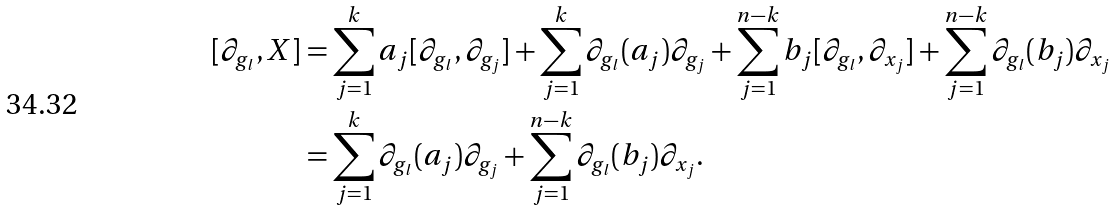Convert formula to latex. <formula><loc_0><loc_0><loc_500><loc_500>[ \partial _ { g _ { l } } , X ] & = \sum _ { j = 1 } ^ { k } a _ { j } [ \partial _ { g _ { l } } , \partial _ { g _ { j } } ] + \sum _ { j = 1 } ^ { k } \partial _ { g _ { l } } ( a _ { j } ) \partial _ { g _ { j } } + \sum _ { j = 1 } ^ { n - k } b _ { j } [ \partial _ { g _ { l } } , \partial _ { x _ { j } } ] + \sum _ { j = 1 } ^ { n - k } \partial _ { g _ { l } } ( b _ { j } ) \partial _ { x _ { j } } \\ & = \sum _ { j = 1 } ^ { k } \partial _ { g _ { l } } ( a _ { j } ) \partial _ { g _ { j } } + \sum _ { j = 1 } ^ { n - k } \partial _ { g _ { l } } ( b _ { j } ) \partial _ { x _ { j } } .</formula> 